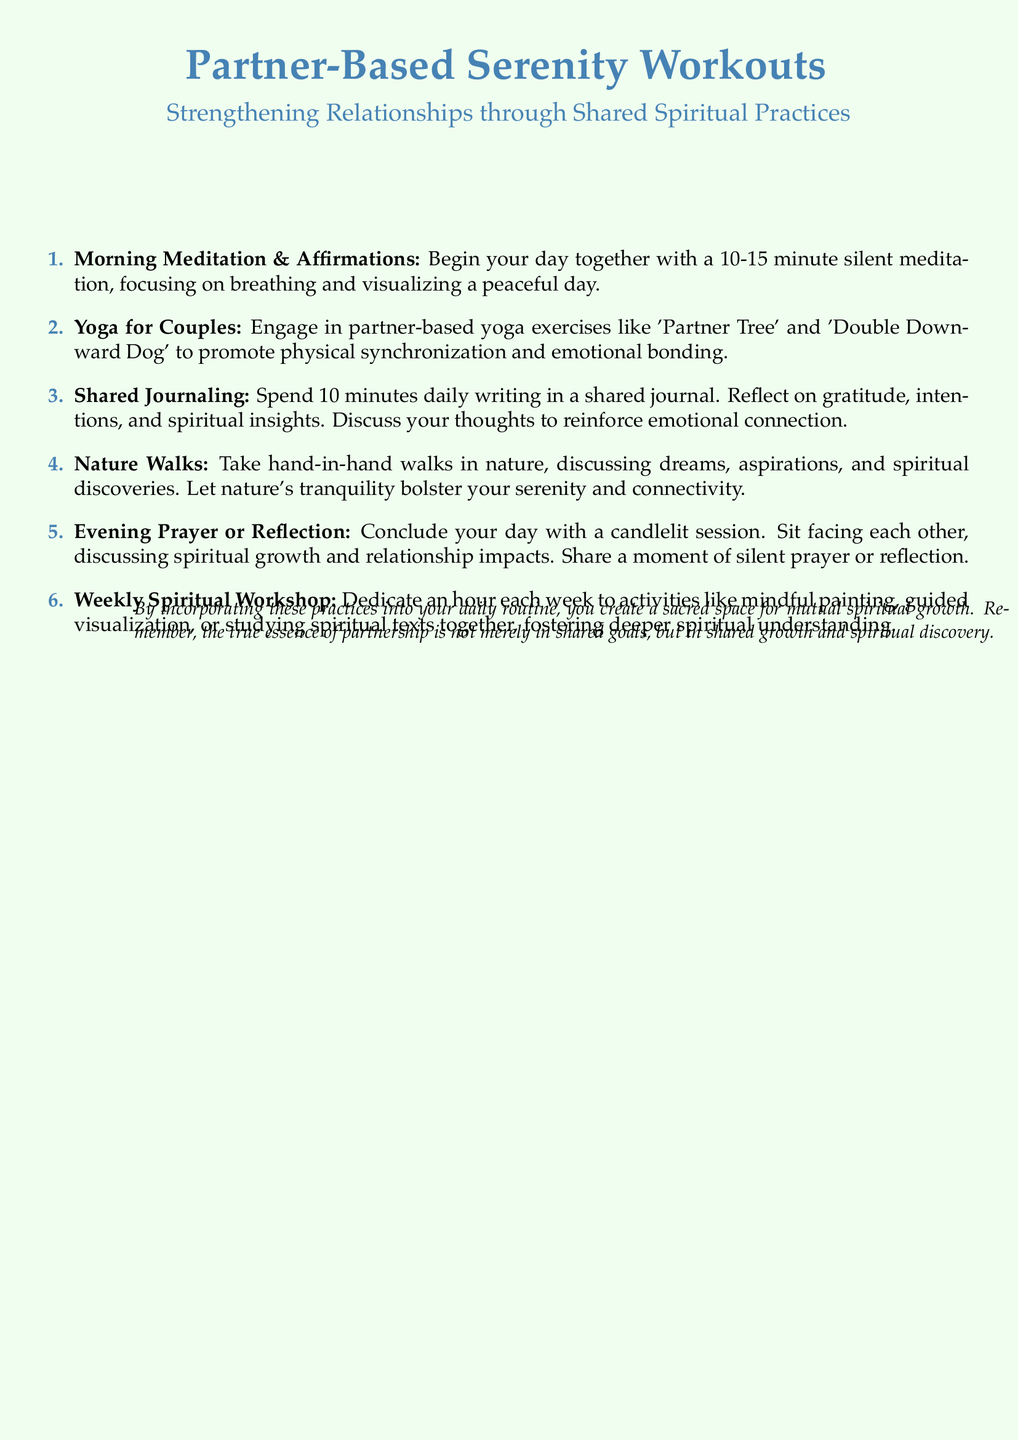What is the name of the workout plan? The workout plan is titled "Partner-Based Serenity Workouts."
Answer: Partner-Based Serenity Workouts How long should the morning meditation last? The document suggests a duration for morning meditation of 10-15 minutes.
Answer: 10-15 minutes What activity promotes physical synchronization and emotional bonding? The activity mentioned for physical synchronization and emotional bonding is partner-based yoga exercises.
Answer: Partner-based yoga exercises What should couples discuss during nature walks? Couples are encouraged to discuss dreams, aspirations, and spiritual discoveries during nature walks.
Answer: Dreams, aspirations, and spiritual discoveries How often should couples engage in a weekly spiritual workshop? The document states that couples should dedicate an hour each week for the workshop.
Answer: Each week What is the final activity of the day mentioned in the document? The final activity of the day mentioned is the evening prayer or reflection session.
Answer: Evening prayer or reflection What should partners reflect on in their shared journaling? Partners should reflect on gratitude, intentions, and spiritual insights in their shared journaling.
Answer: Gratitude, intentions, and spiritual insights What color is used for headings in the document? The color used for headings is called spiritual blue.
Answer: Spiritual blue 